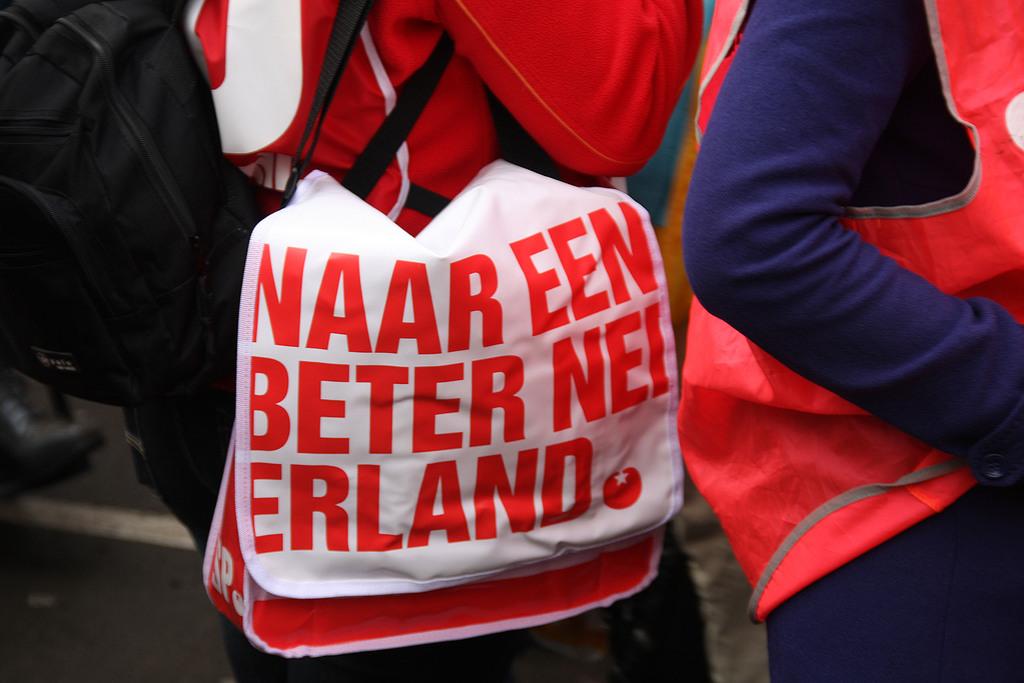What's the first word on the second line?
Give a very brief answer. Beter. What does the bag say?
Your answer should be compact. Naar een beter nei erland. 